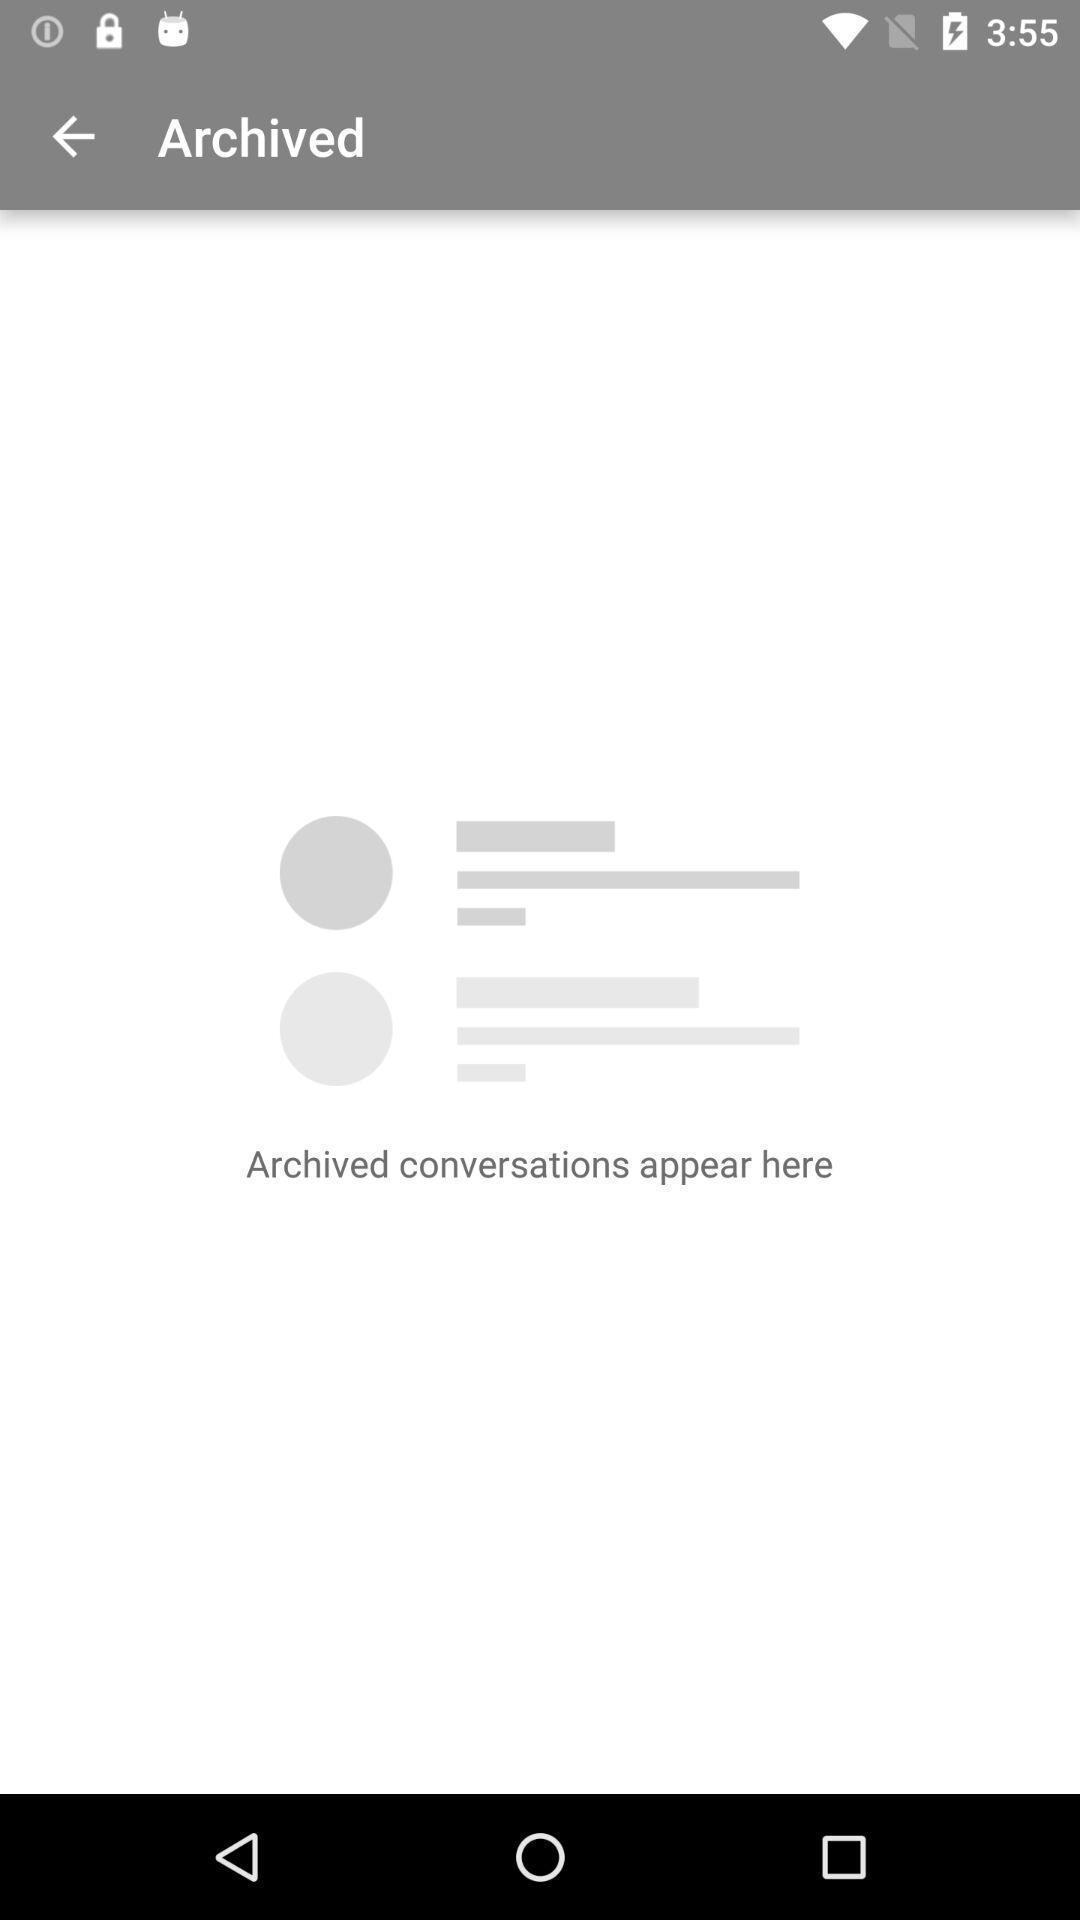Explain the elements present in this screenshot. Page showing your archived messages. 